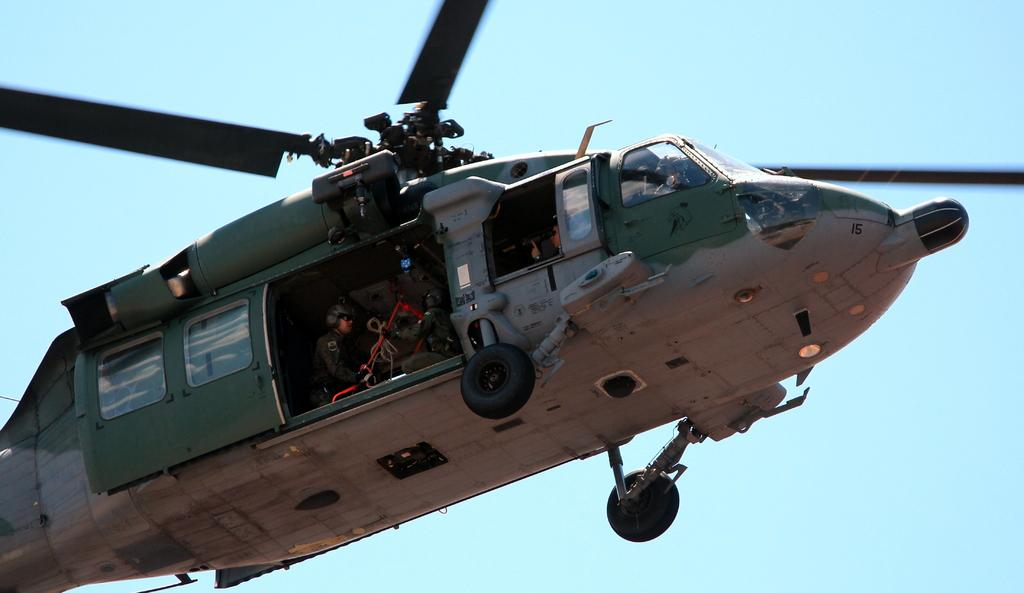What is the main subject of the picture? The main subject of the picture is a helicopter. What is the helicopter doing in the image? The helicopter is flying in the image. Are there any passengers inside the helicopter? Yes, there are people inside the helicopter. What can be seen inside the helicopter besides the people? There are objects visible inside the helicopter. What is visible in the background of the image? The sky is visible in the background of the image. Who is the owner of the lettuce in the image? There is no lettuce present in the image. How does the helicopter sort the objects inside it? The helicopter does not sort objects; it is simply flying with people and objects inside it. 